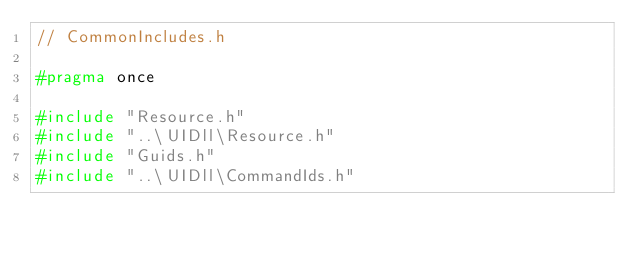Convert code to text. <code><loc_0><loc_0><loc_500><loc_500><_C_>// CommonIncludes.h

#pragma once

#include "Resource.h"
#include "..\UIDll\Resource.h"
#include "Guids.h"
#include "..\UIDll\CommandIds.h"



</code> 